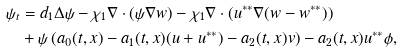Convert formula to latex. <formula><loc_0><loc_0><loc_500><loc_500>\psi _ { t } & = d _ { 1 } \Delta \psi - \chi _ { 1 } \nabla \cdot ( \psi \nabla w ) - \chi _ { 1 } \nabla \cdot ( u ^ { * * } \nabla ( w - w ^ { * * } ) ) \\ & + \psi \left ( a _ { 0 } ( t , x ) - a _ { 1 } ( t , x ) ( u + u ^ { * * } ) - a _ { 2 } ( t , x ) v \right ) - a _ { 2 } ( t , x ) u ^ { * * } \phi ,</formula> 